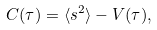<formula> <loc_0><loc_0><loc_500><loc_500>C ( \tau ) = \langle s ^ { 2 } \rangle - V ( \tau ) ,</formula> 